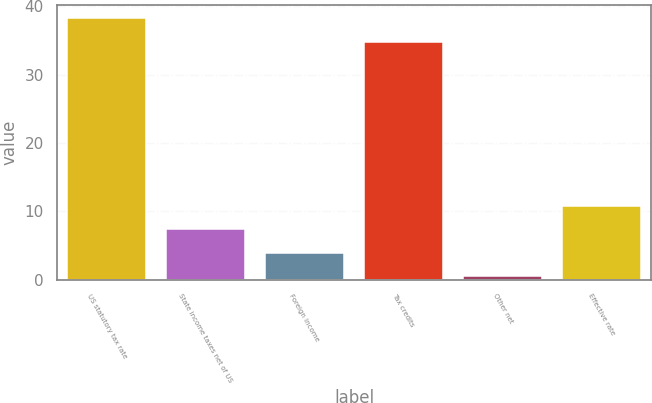<chart> <loc_0><loc_0><loc_500><loc_500><bar_chart><fcel>US statutory tax rate<fcel>State income taxes net of US<fcel>Foreign income<fcel>Tax credits<fcel>Other net<fcel>Effective rate<nl><fcel>38.25<fcel>7.4<fcel>3.95<fcel>34.8<fcel>0.5<fcel>10.85<nl></chart> 